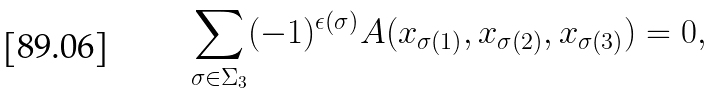<formula> <loc_0><loc_0><loc_500><loc_500>\sum _ { \sigma \in \Sigma _ { 3 } } ( - 1 ) ^ { \epsilon ( \sigma ) } A ( x _ { \sigma ( 1 ) } , x _ { \sigma ( 2 ) } , x _ { \sigma ( 3 ) } ) = 0 ,</formula> 